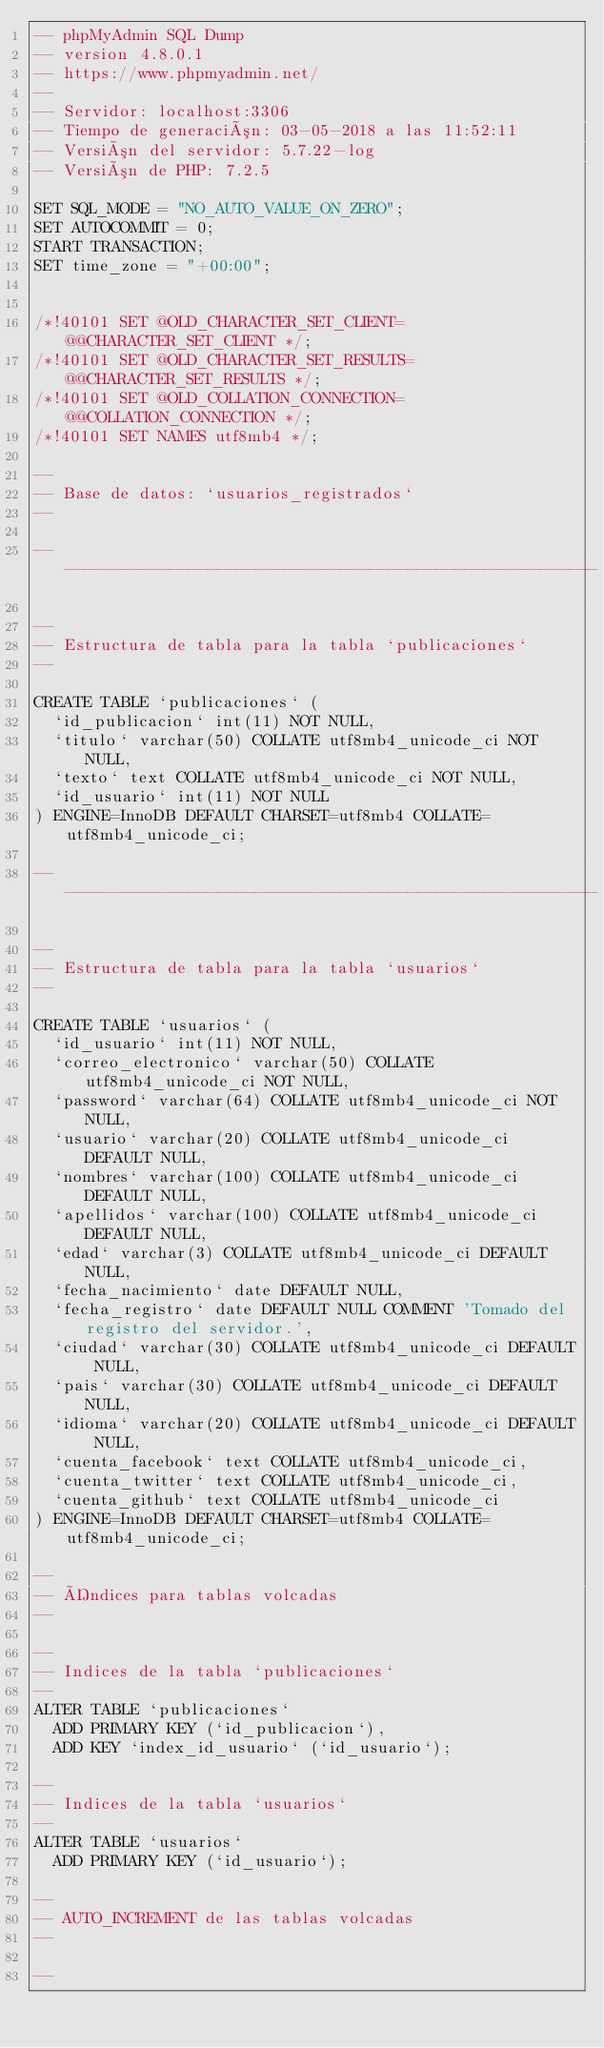<code> <loc_0><loc_0><loc_500><loc_500><_SQL_>-- phpMyAdmin SQL Dump
-- version 4.8.0.1
-- https://www.phpmyadmin.net/
--
-- Servidor: localhost:3306
-- Tiempo de generación: 03-05-2018 a las 11:52:11
-- Versión del servidor: 5.7.22-log
-- Versión de PHP: 7.2.5

SET SQL_MODE = "NO_AUTO_VALUE_ON_ZERO";
SET AUTOCOMMIT = 0;
START TRANSACTION;
SET time_zone = "+00:00";


/*!40101 SET @OLD_CHARACTER_SET_CLIENT=@@CHARACTER_SET_CLIENT */;
/*!40101 SET @OLD_CHARACTER_SET_RESULTS=@@CHARACTER_SET_RESULTS */;
/*!40101 SET @OLD_COLLATION_CONNECTION=@@COLLATION_CONNECTION */;
/*!40101 SET NAMES utf8mb4 */;

--
-- Base de datos: `usuarios_registrados`
--

-- --------------------------------------------------------

--
-- Estructura de tabla para la tabla `publicaciones`
--

CREATE TABLE `publicaciones` (
  `id_publicacion` int(11) NOT NULL,
  `titulo` varchar(50) COLLATE utf8mb4_unicode_ci NOT NULL,
  `texto` text COLLATE utf8mb4_unicode_ci NOT NULL,
  `id_usuario` int(11) NOT NULL
) ENGINE=InnoDB DEFAULT CHARSET=utf8mb4 COLLATE=utf8mb4_unicode_ci;

-- --------------------------------------------------------

--
-- Estructura de tabla para la tabla `usuarios`
--

CREATE TABLE `usuarios` (
  `id_usuario` int(11) NOT NULL,
  `correo_electronico` varchar(50) COLLATE utf8mb4_unicode_ci NOT NULL,
  `password` varchar(64) COLLATE utf8mb4_unicode_ci NOT NULL,
  `usuario` varchar(20) COLLATE utf8mb4_unicode_ci DEFAULT NULL,
  `nombres` varchar(100) COLLATE utf8mb4_unicode_ci DEFAULT NULL,
  `apellidos` varchar(100) COLLATE utf8mb4_unicode_ci DEFAULT NULL,
  `edad` varchar(3) COLLATE utf8mb4_unicode_ci DEFAULT NULL,
  `fecha_nacimiento` date DEFAULT NULL,
  `fecha_registro` date DEFAULT NULL COMMENT 'Tomado del registro del servidor.',
  `ciudad` varchar(30) COLLATE utf8mb4_unicode_ci DEFAULT NULL,
  `pais` varchar(30) COLLATE utf8mb4_unicode_ci DEFAULT NULL,
  `idioma` varchar(20) COLLATE utf8mb4_unicode_ci DEFAULT NULL,
  `cuenta_facebook` text COLLATE utf8mb4_unicode_ci,
  `cuenta_twitter` text COLLATE utf8mb4_unicode_ci,
  `cuenta_github` text COLLATE utf8mb4_unicode_ci
) ENGINE=InnoDB DEFAULT CHARSET=utf8mb4 COLLATE=utf8mb4_unicode_ci;

--
-- Índices para tablas volcadas
--

--
-- Indices de la tabla `publicaciones`
--
ALTER TABLE `publicaciones`
  ADD PRIMARY KEY (`id_publicacion`),
  ADD KEY `index_id_usuario` (`id_usuario`);

--
-- Indices de la tabla `usuarios`
--
ALTER TABLE `usuarios`
  ADD PRIMARY KEY (`id_usuario`);

--
-- AUTO_INCREMENT de las tablas volcadas
--

--</code> 